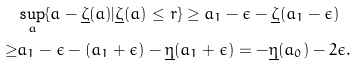Convert formula to latex. <formula><loc_0><loc_0><loc_500><loc_500>& \sup _ { a } \{ a - \underline { \zeta } ( a ) | \underline { \zeta } ( a ) \leq r \} \geq a _ { 1 } - \epsilon - \underline { \zeta } ( a _ { 1 } - \epsilon ) \\ \geq & a _ { 1 } - \epsilon - ( a _ { 1 } + \epsilon ) - \underline { \eta } ( a _ { 1 } + \epsilon ) = - \underline { \eta } ( a _ { 0 } ) - 2 \epsilon .</formula> 